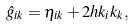Convert formula to latex. <formula><loc_0><loc_0><loc_500><loc_500>\hat { g } _ { i k } = \eta _ { i k } + 2 h k _ { i } k _ { k } ,</formula> 